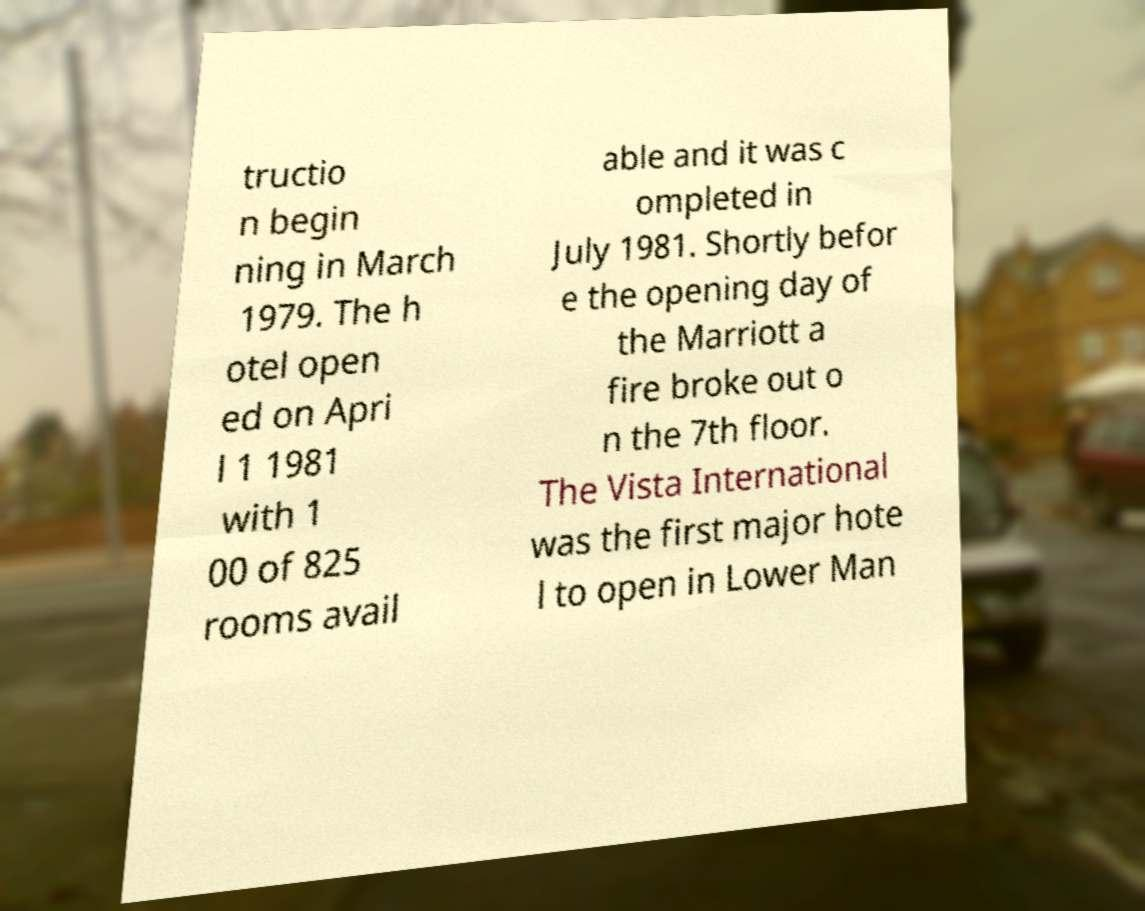Could you assist in decoding the text presented in this image and type it out clearly? tructio n begin ning in March 1979. The h otel open ed on Apri l 1 1981 with 1 00 of 825 rooms avail able and it was c ompleted in July 1981. Shortly befor e the opening day of the Marriott a fire broke out o n the 7th floor. The Vista International was the first major hote l to open in Lower Man 